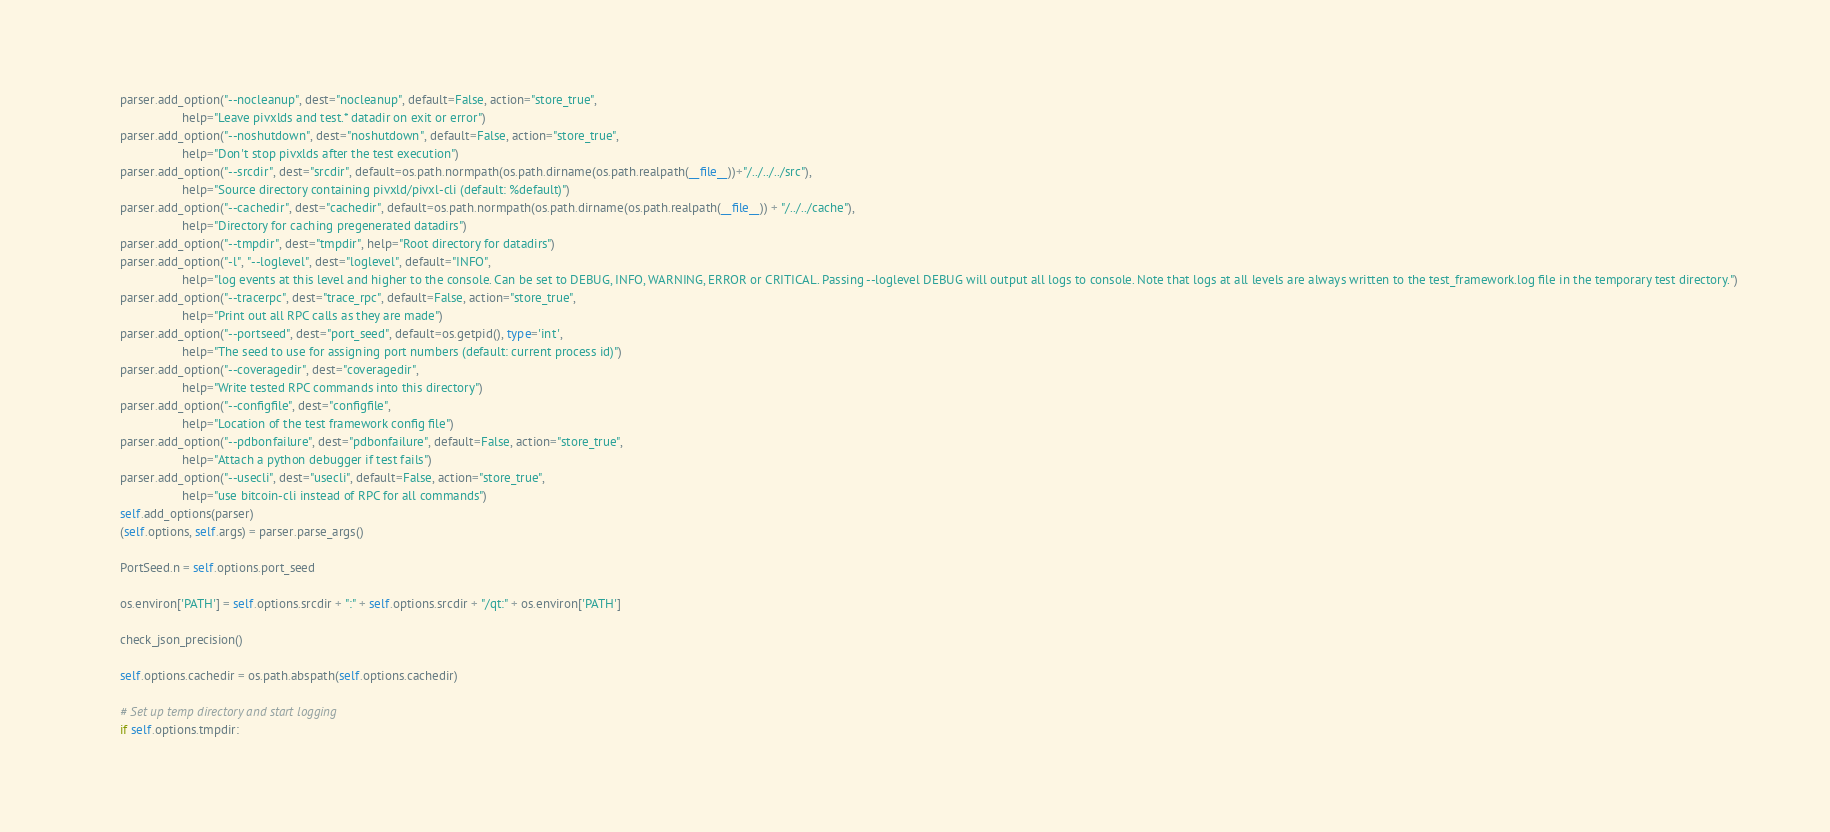Convert code to text. <code><loc_0><loc_0><loc_500><loc_500><_Python_>        parser.add_option("--nocleanup", dest="nocleanup", default=False, action="store_true",
                          help="Leave pivxlds and test.* datadir on exit or error")
        parser.add_option("--noshutdown", dest="noshutdown", default=False, action="store_true",
                          help="Don't stop pivxlds after the test execution")
        parser.add_option("--srcdir", dest="srcdir", default=os.path.normpath(os.path.dirname(os.path.realpath(__file__))+"/../../../src"),
                          help="Source directory containing pivxld/pivxl-cli (default: %default)")
        parser.add_option("--cachedir", dest="cachedir", default=os.path.normpath(os.path.dirname(os.path.realpath(__file__)) + "/../../cache"),
                          help="Directory for caching pregenerated datadirs")
        parser.add_option("--tmpdir", dest="tmpdir", help="Root directory for datadirs")
        parser.add_option("-l", "--loglevel", dest="loglevel", default="INFO",
                          help="log events at this level and higher to the console. Can be set to DEBUG, INFO, WARNING, ERROR or CRITICAL. Passing --loglevel DEBUG will output all logs to console. Note that logs at all levels are always written to the test_framework.log file in the temporary test directory.")
        parser.add_option("--tracerpc", dest="trace_rpc", default=False, action="store_true",
                          help="Print out all RPC calls as they are made")
        parser.add_option("--portseed", dest="port_seed", default=os.getpid(), type='int',
                          help="The seed to use for assigning port numbers (default: current process id)")
        parser.add_option("--coveragedir", dest="coveragedir",
                          help="Write tested RPC commands into this directory")
        parser.add_option("--configfile", dest="configfile",
                          help="Location of the test framework config file")
        parser.add_option("--pdbonfailure", dest="pdbonfailure", default=False, action="store_true",
                          help="Attach a python debugger if test fails")
        parser.add_option("--usecli", dest="usecli", default=False, action="store_true",
                          help="use bitcoin-cli instead of RPC for all commands")
        self.add_options(parser)
        (self.options, self.args) = parser.parse_args()

        PortSeed.n = self.options.port_seed

        os.environ['PATH'] = self.options.srcdir + ":" + self.options.srcdir + "/qt:" + os.environ['PATH']

        check_json_precision()

        self.options.cachedir = os.path.abspath(self.options.cachedir)

        # Set up temp directory and start logging
        if self.options.tmpdir:</code> 